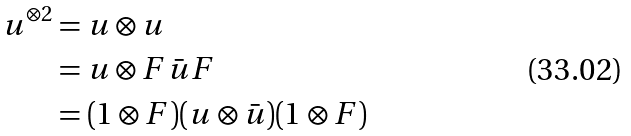<formula> <loc_0><loc_0><loc_500><loc_500>u ^ { \otimes 2 } & = u \otimes u \\ & = u \otimes F \bar { u } F \\ & = ( 1 \otimes F ) ( u \otimes \bar { u } ) ( 1 \otimes F )</formula> 